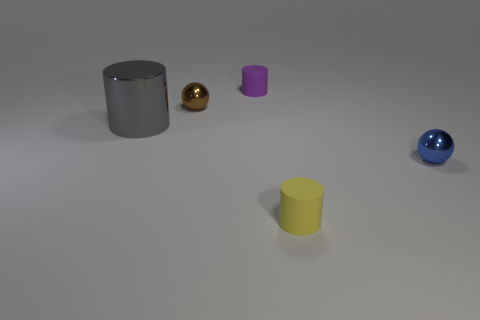How many things are small metal things to the left of the purple rubber object or large red matte objects?
Offer a terse response. 1. The thing on the left side of the tiny metal thing that is to the left of the yellow thing is what shape?
Keep it short and to the point. Cylinder. Do the tiny metal thing left of the yellow rubber cylinder and the blue thing have the same shape?
Provide a succinct answer. Yes. There is a small shiny ball that is in front of the brown thing; what is its color?
Offer a very short reply. Blue. How many balls are either yellow rubber things or small metal things?
Your answer should be very brief. 2. What is the size of the matte cylinder behind the rubber object that is in front of the gray metallic thing?
Offer a very short reply. Small. There is a brown shiny object; what number of tiny things are in front of it?
Offer a very short reply. 2. Are there fewer small brown shiny things than big green shiny cubes?
Your answer should be very brief. No. There is a metallic object that is to the right of the gray object and on the left side of the small yellow cylinder; what size is it?
Your answer should be compact. Small. Are there fewer big metal things in front of the yellow cylinder than big red cubes?
Provide a succinct answer. No. 